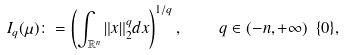Convert formula to latex. <formula><loc_0><loc_0><loc_500><loc_500>I _ { q } ( \mu ) \colon = \left ( \int _ { { \mathbb { R } } ^ { n } } \| x \| _ { 2 } ^ { q } d x \right ) ^ { 1 / q } , \quad q \in ( - n , + \infty ) \ \{ 0 \} ,</formula> 